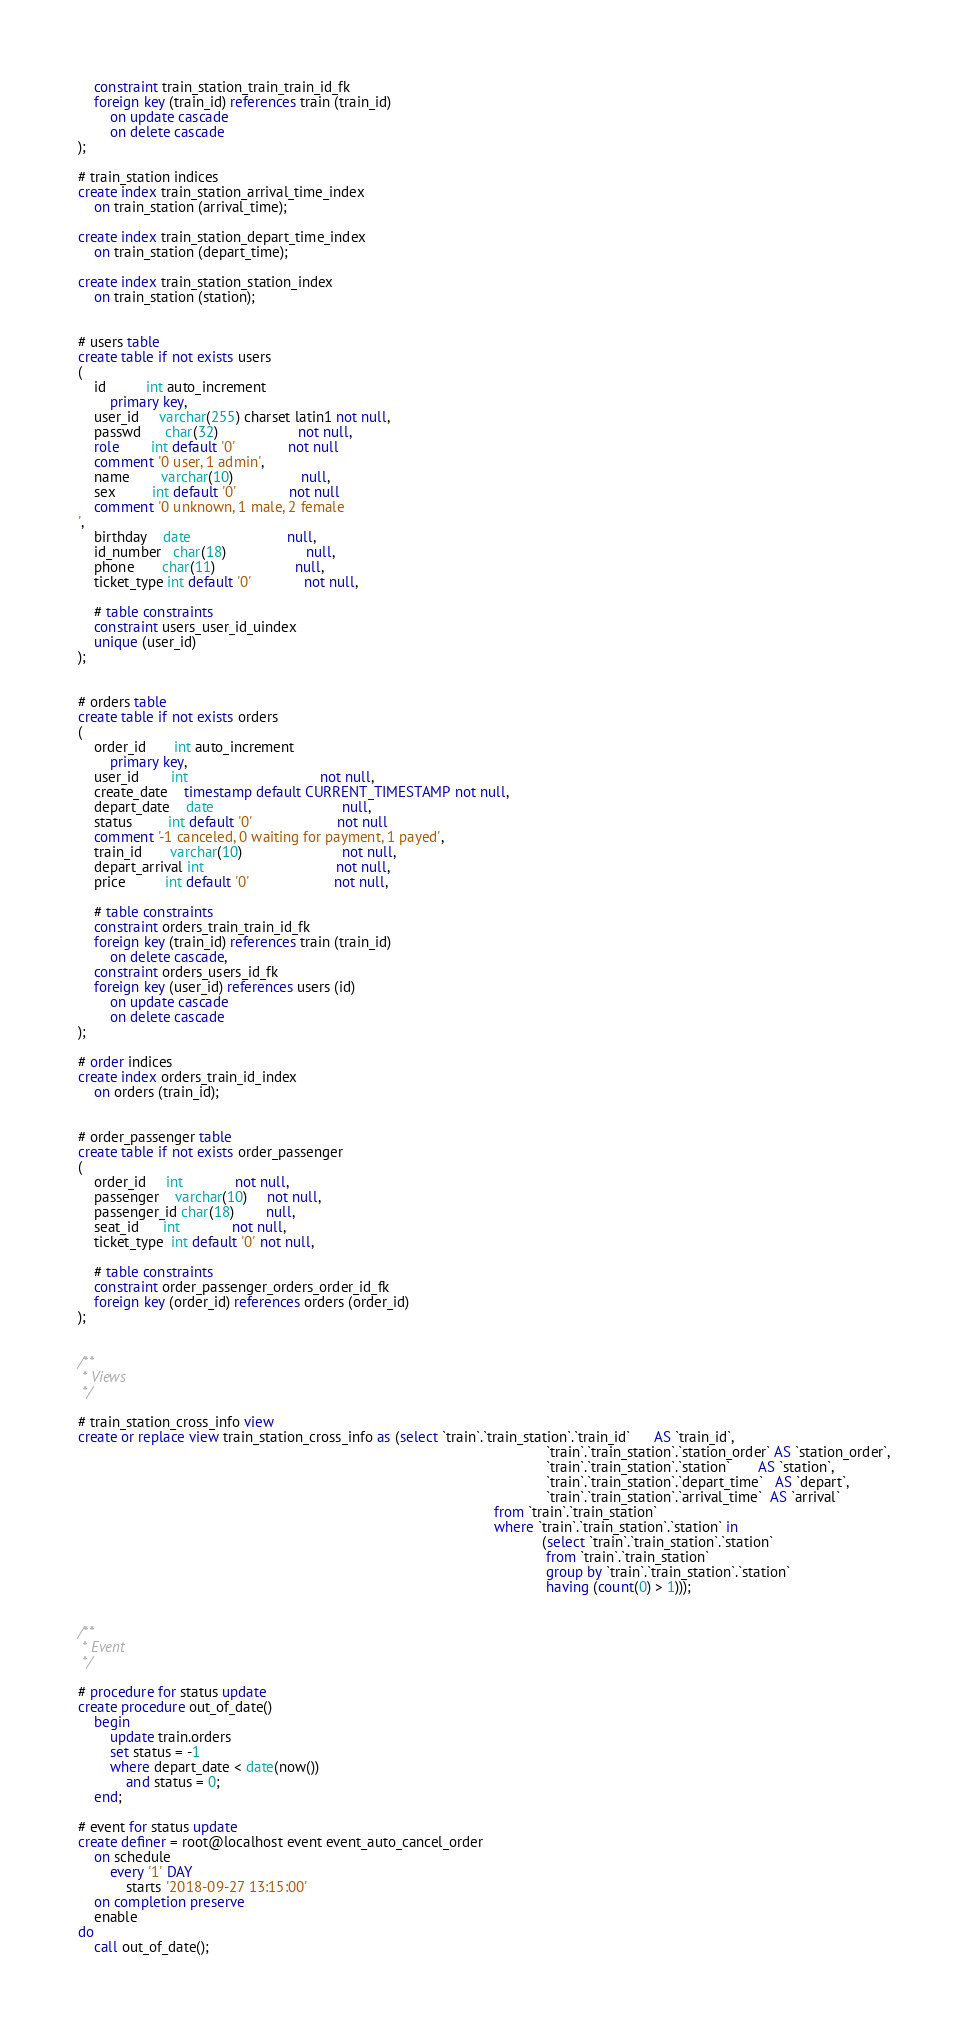<code> <loc_0><loc_0><loc_500><loc_500><_SQL_>	constraint train_station_train_train_id_fk
	foreign key (train_id) references train (train_id)
		on update cascade
		on delete cascade
);

# train_station indices
create index train_station_arrival_time_index
	on train_station (arrival_time);

create index train_station_depart_time_index
	on train_station (depart_time);

create index train_station_station_index
	on train_station (station);


# users table
create table if not exists users
(
	id          int auto_increment
		primary key,
	user_id     varchar(255) charset latin1 not null,
	passwd      char(32)                    not null,
	role        int default '0'             not null
	comment '0 user, 1 admin',
	name        varchar(10)                 null,
	sex         int default '0'             not null
	comment '0 unknown, 1 male, 2 female
',
	birthday    date                        null,
	id_number   char(18)                    null,
	phone       char(11)                    null,
	ticket_type int default '0'             not null,
	
	# table constraints
	constraint users_user_id_uindex
	unique (user_id)
);


# orders table
create table if not exists orders
(
	order_id       int auto_increment
		primary key,
	user_id        int                                 not null,
	create_date    timestamp default CURRENT_TIMESTAMP not null,
	depart_date    date                                null,
	status         int default '0'                     not null
	comment '-1 canceled, 0 waiting for payment, 1 payed',
	train_id       varchar(10)                         not null,
	depart_arrival int                                 not null,
	price          int default '0'                     not null,
	
	# table constraints
	constraint orders_train_train_id_fk
	foreign key (train_id) references train (train_id)
		on delete cascade,
	constraint orders_users_id_fk
	foreign key (user_id) references users (id)
		on update cascade
		on delete cascade
);

# order indices
create index orders_train_id_index
	on orders (train_id);


# order_passenger table
create table if not exists order_passenger
(
	order_id     int             not null,
	passenger    varchar(10)     not null,
	passenger_id char(18)        null,
	seat_id      int             not null,
	ticket_type  int default '0' not null,
	
	# table constraints
	constraint order_passenger_orders_order_id_fk
	foreign key (order_id) references orders (order_id)
);


/**
 * Views
 */

# train_station_cross_info view
create or replace view train_station_cross_info as (select `train`.`train_station`.`train_id`      AS `train_id`,
																													 `train`.`train_station`.`station_order` AS `station_order`,
																													 `train`.`train_station`.`station`       AS `station`,
																													 `train`.`train_station`.`depart_time`   AS `depart`,
																													 `train`.`train_station`.`arrival_time`  AS `arrival`
																										from `train`.`train_station`
																										where `train`.`train_station`.`station` in
																													(select `train`.`train_station`.`station`
																													 from `train`.`train_station`
																													 group by `train`.`train_station`.`station`
																													 having (count(0) > 1)));


/**
 * Event
 */

# procedure for status update
create procedure out_of_date()
	begin
		update train.orders
		set status = -1
		where depart_date < date(now())
			and status = 0;
	end;

# event for status update
create definer = root@localhost event event_auto_cancel_order
	on schedule
		every '1' DAY
			starts '2018-09-27 13:15:00'
	on completion preserve
	enable
do
	call out_of_date();
</code> 